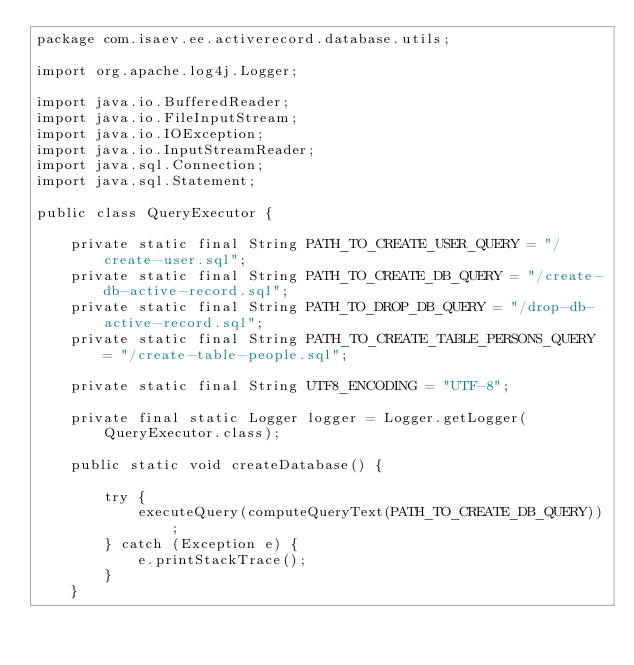Convert code to text. <code><loc_0><loc_0><loc_500><loc_500><_Java_>package com.isaev.ee.activerecord.database.utils;

import org.apache.log4j.Logger;

import java.io.BufferedReader;
import java.io.FileInputStream;
import java.io.IOException;
import java.io.InputStreamReader;
import java.sql.Connection;
import java.sql.Statement;

public class QueryExecutor {

    private static final String PATH_TO_CREATE_USER_QUERY = "/create-user.sql";
    private static final String PATH_TO_CREATE_DB_QUERY = "/create-db-active-record.sql";
    private static final String PATH_TO_DROP_DB_QUERY = "/drop-db-active-record.sql";
    private static final String PATH_TO_CREATE_TABLE_PERSONS_QUERY = "/create-table-people.sql";

    private static final String UTF8_ENCODING = "UTF-8";

    private final static Logger logger = Logger.getLogger(QueryExecutor.class);

    public static void createDatabase() {

        try {
            executeQuery(computeQueryText(PATH_TO_CREATE_DB_QUERY));
        } catch (Exception e) {
            e.printStackTrace();
        }
    }
</code> 